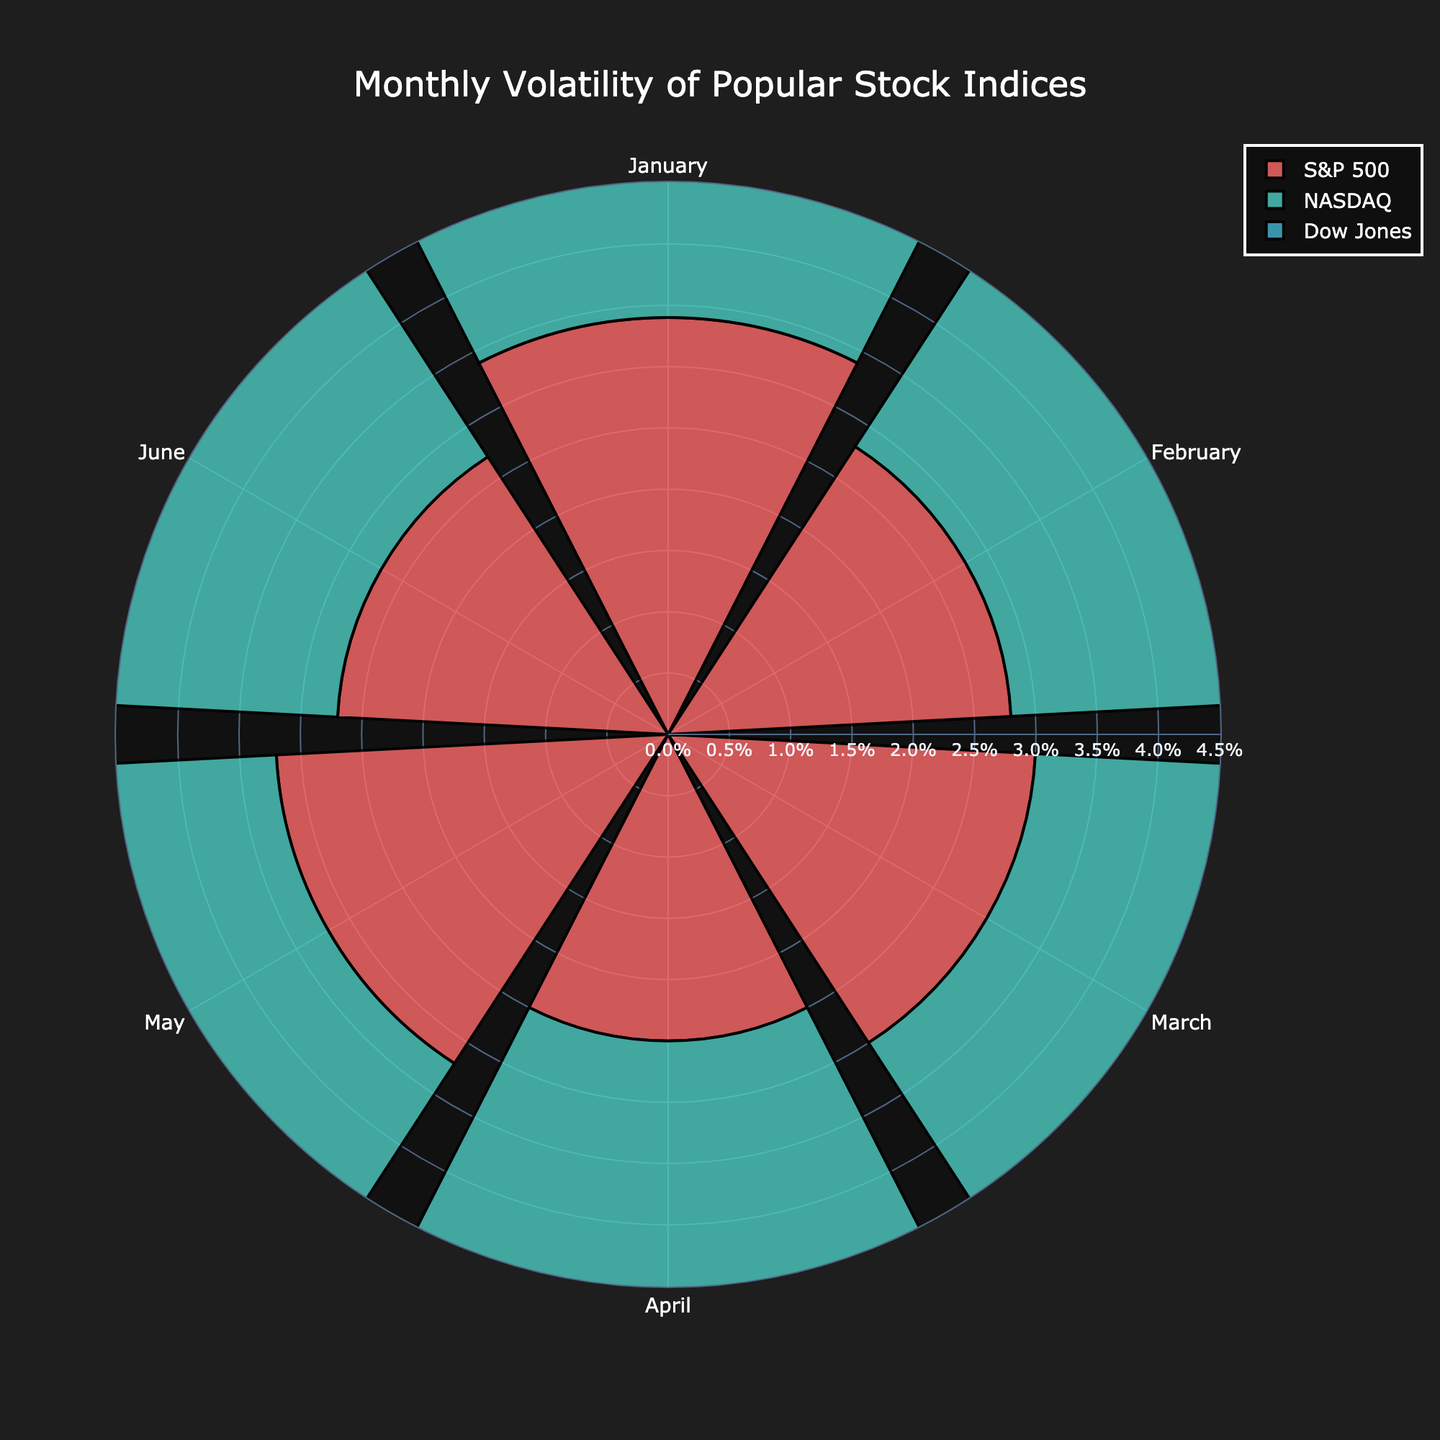What is the title of the rose chart? The title of a chart is usually displayed at the top and provides a summary of what the chart represents. In this case, the title of the rose chart is "Monthly Volatility of Popular Stock Indices" as specified in the layout configurations.
Answer: Monthly Volatility of Popular Stock Indices How does the volatility of the NASDAQ in March compare to that in January? To answer this, one must look at the bar lengths for NASDAQ in both March and January. The chart shows that the volatility for NASDAQ in March is smaller than that in January as the length of the bar for March is shorter compared to that for January (3.8% in March vs. 4.0% in January).
Answer: NASDAQ volatility in March is less than in January Which month shows the lowest volatility for the Dow Jones index? By observing the lengths of the bars for Dow Jones across all months, the shortest bar will represent the lowest volatility. For Dow Jones, the shortest bar is for April, indicating the lowest volatility.
Answer: April What is the average volatility of the S&P 500 over the six months? To find the average volatility, take the sum of the individual volatilities for the S&P 500 over the six months and divide by the number of months. The volatilities are 3.4%, 2.8%, 3.0%, 2.5%, 3.2%, and 2.7%. The sum is 17.6%, and the average is 17.6% / 6 = 2.93%.
Answer: 2.93% Considering all three indices, which month has the highest combined volatility? Sum the volatilities for each month across all three indices and compare the sums. For January: 3.4% + 4.0% + 2.9% = 10.3%. For February: 2.8% + 3.5% + 2.4% = 8.7%. For March: 3.0% + 3.8% + 2.7% = 9.5%. For April: 2.5% + 3.2% + 2.3% = 8.0%. For May: 3.2% + 4.1% + 2.8% = 10.1%. For June: 2.7% + 3.6% + 2.5% = 8.8%. January has the highest combined volatility of 10.3%.
Answer: January Which index shows the least variability in volatility over the six months? To determine this, look for the index where the lengths of the bars are the most consistent or have the smallest range between the highest and lowest bars. The Dow Jones has the least variability, with volatilities ranging from 2.3% to 2.9%, which is a range of 0.6%.
Answer: Dow Jones Between NASDAQ and S&P 500, which has higher volatility in May? Compare the lengths of the bars for NASDAQ and S&P 500 in May. The NASDAQ shows higher volatility at 4.1%, whereas the S&P 500 has 3.2%.
Answer: NASDAQ What is the difference in volatility between the highest and lowest months for the NASDAQ index? Identify the highest and lowest volatility months for NASDAQ. The highest is May at 4.1%, and the lowest is April at 3.2%. The difference is 4.1% - 3.2% = 0.9%.
Answer: 0.9% In which month do all three indices show the lowest volatility? To find this, compare the lowest volatilities of the three indices across all months. The lowest individual volatilities are: January (S&P 500: 3.4%, NASDAQ: 4.0%, Dow Jones: 2.9%), February (S&P 500: 2.8%, NASDAQ: 3.5%, Dow Jones: 2.4%), March (S&P 500: 3.0%, NASDAQ: 3.8%, Dow Jones: 2.7%), April (S&P 500: 2.5%, NASDAQ: 3.2%, Dow Jones: 2.3%), May (S&P 500: 3.2%, NASDAQ: 4.1%, Dow Jones: 2.8%), and June (S&P 500: 2.7%, NASDAQ: 3.6%, Dow Jones: 2.5%). April has the lowest combined individual volatilities.
Answer: April 